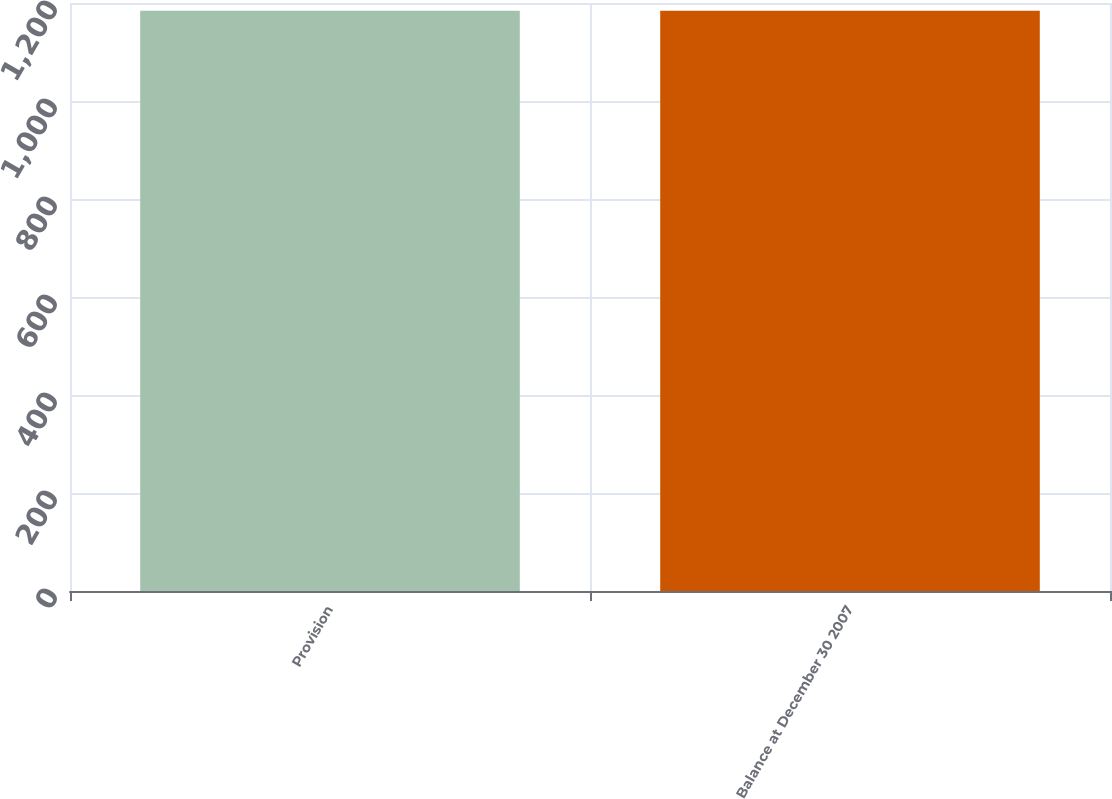Convert chart. <chart><loc_0><loc_0><loc_500><loc_500><bar_chart><fcel>Provision<fcel>Balance at December 30 2007<nl><fcel>1184<fcel>1184.1<nl></chart> 